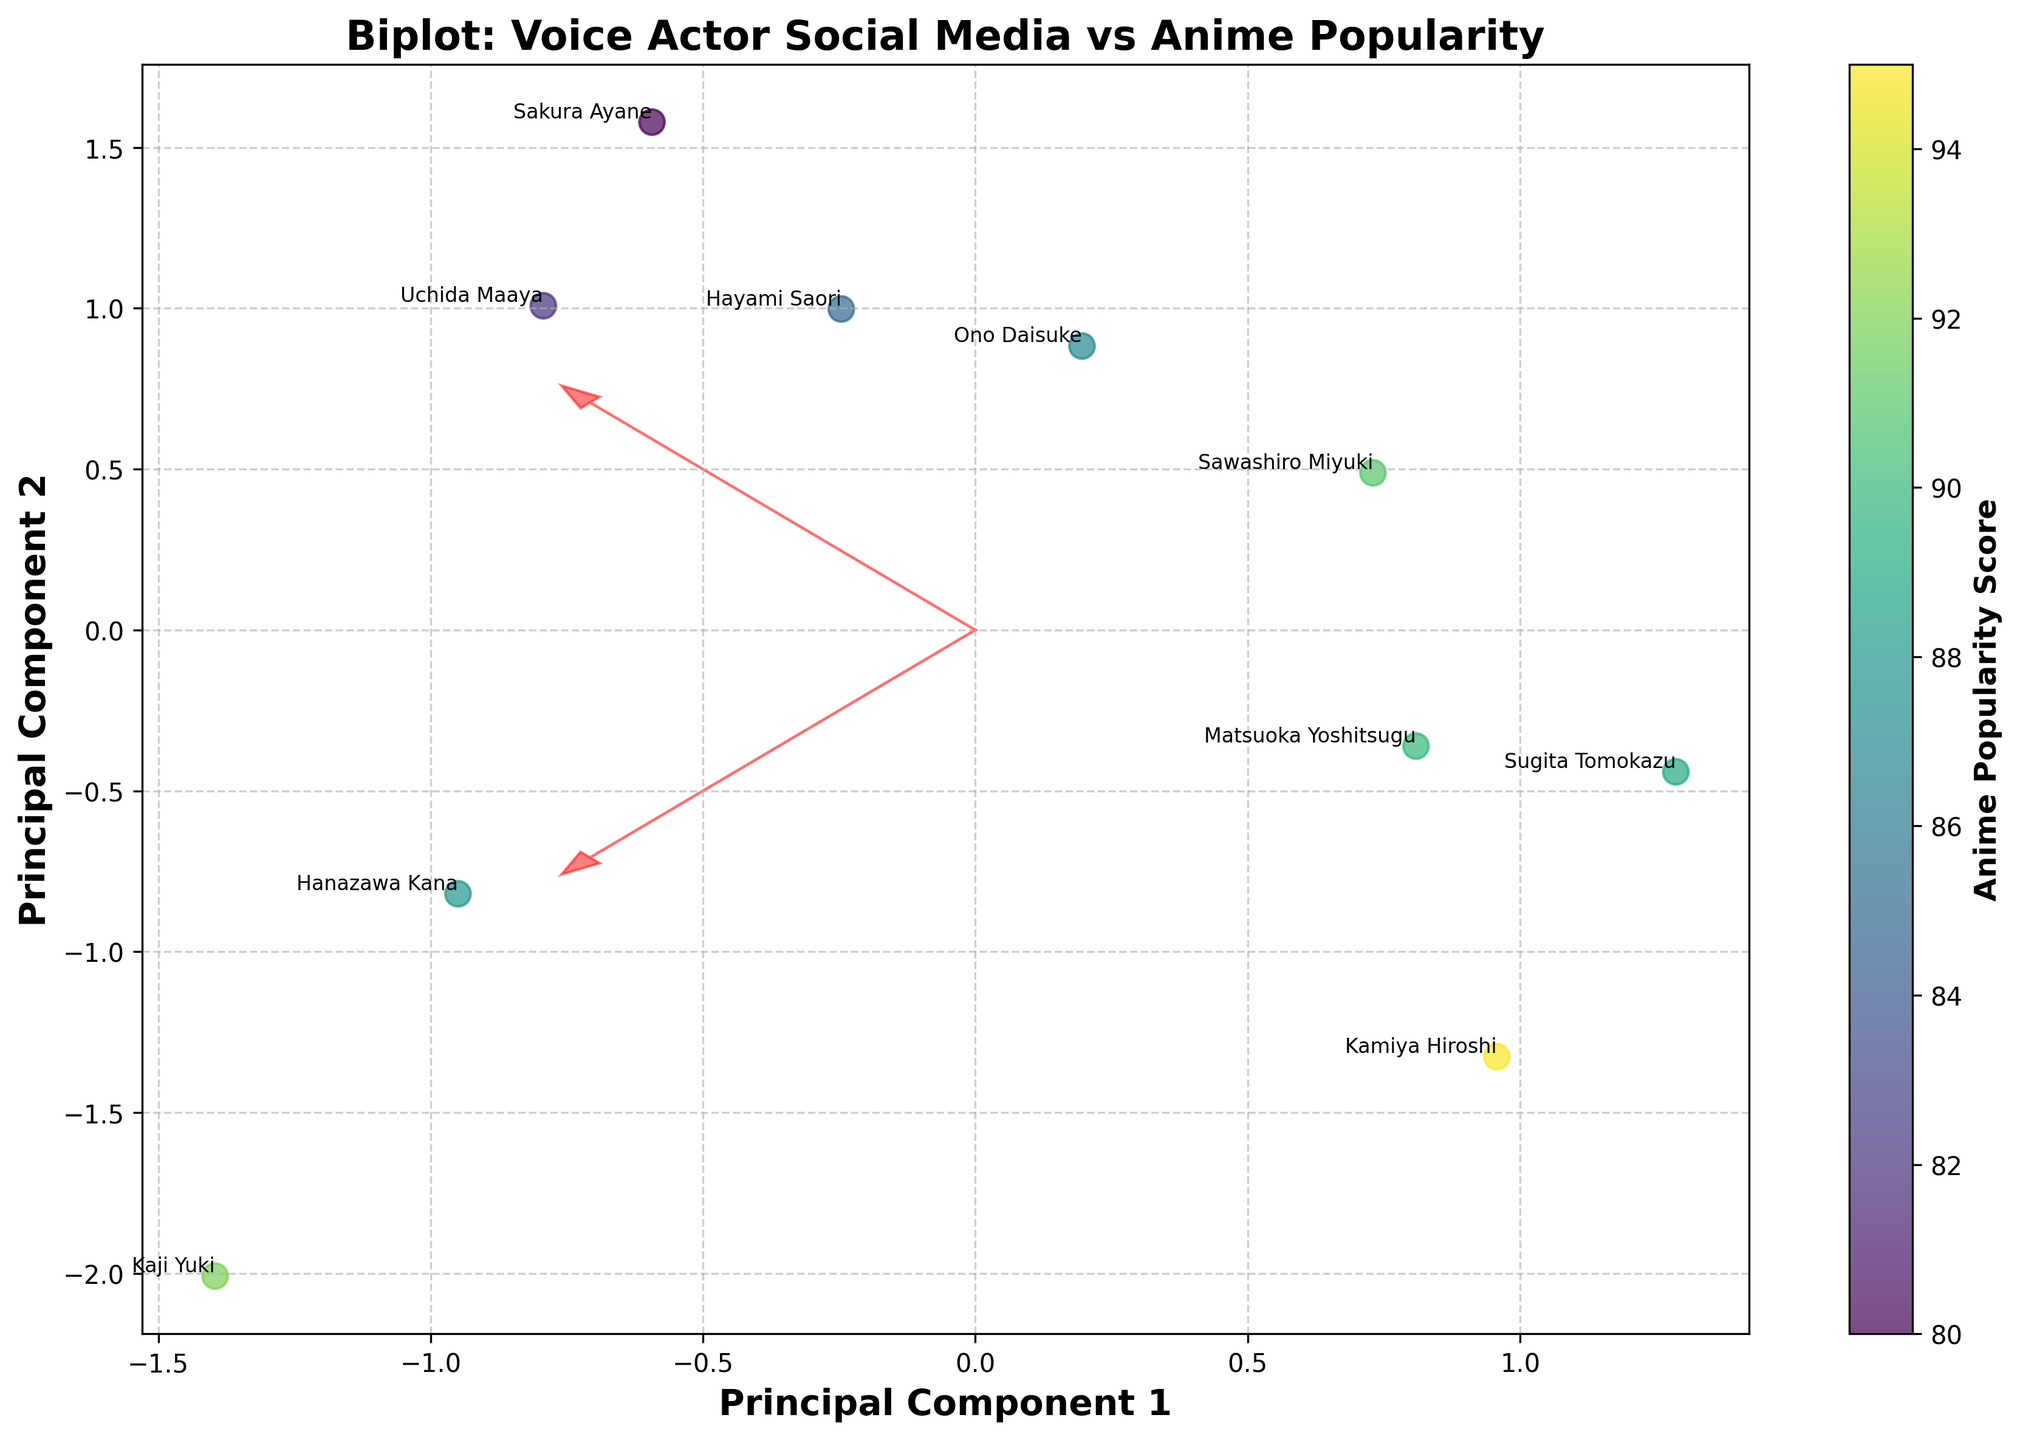What is the title of the plot? The title of the plot is typically located at the top of the figure. In this case, it clearly says "Biplot: Voice Actor Social Media vs Anime Popularity".
Answer: Biplot: Voice Actor Social Media vs Anime Popularity How many data points are represented in the plot? Each voice actor in the dataset is represented as a point. By counting these, we can see there are 10 voice actors.
Answer: 10 Which voice actor has the highest Anime Popularity Score, based on their color? By observing the color gradient in the plot where higher Anime Popularity Scores are represented by lighter shades, Kamiya Hiroshi appears to have the highest Anime Popularity Score.
Answer: Kamiya Hiroshi What do the arrows in the plot represent? The arrows in a biplot typically represent the eigenvectors of the principal components, showing the direction and magnitude of the original variables. In this plot, they represent the direction and magnitude of 'Follower Count' and 'Engagement Rate'.
Answer: Eigenvectors of the principal components Which voice actors are closest to each other on the biplot, and what might this imply? Kaji Yuki and Matsuoka Yoshitsugu are close to each other on the biplot, suggesting they have similar follower counts and engagement rates when standardized.
Answer: Kaji Yuki and Matsuoka Yoshitsugu Is there a visible correlation between the principal components and Anime Popularity Score? By examining the scatter plot and the color gradient, there appears to be some correlation. For instance, points with higher Anime Popularity Scores are generally more aligned with PC1, indicating that Anime Popularity Score might have a relationship with one of the principal components.
Answer: Yes How does Uchida Maaya's position in the biplot compare with Hayami Saori's position? Uchida Maaya is positioned lower in the second principal component compared to Hayami Saori, indicating differences in their standardized follower count and engagement rate.
Answer: Uchida Maaya is lower in PC2 than Hayami Saori Are there any voice actors with a high engagement rate but a relatively low follower count? Sugita Tomokazu, located in a position that correlates to high engagement but not high follower count, fits this description.
Answer: Sugita Tomokazu What is the significance of Kamiya Hiroshi's placement on the plot in terms of both principal components? Kamiya Hiroshi is positioned high on PC1 and moderate on PC2, suggesting that he has a significant follower count and engagement rate that differ from others along these principal components.
Answer: High on PC1, moderate on PC2 How do the positions of Sawashiro Miyuki and Ono Daisuke compare in relation to the eigenvectors? Sawashiro Miyuki is located closer along the direction of one of the eigenvectors, indicating a stronger relationship with either 'Follower Count' or 'Engagement Rate' as compared to Ono Daisuke.
Answer: Sawashiro Miyuki is closer to an eigenvector than Ono Daisuke 